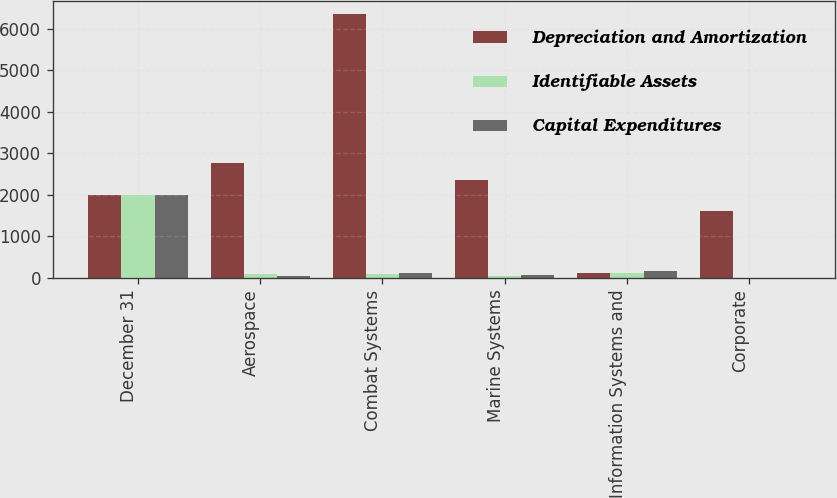Convert chart. <chart><loc_0><loc_0><loc_500><loc_500><stacked_bar_chart><ecel><fcel>December 31<fcel>Aerospace<fcel>Combat Systems<fcel>Marine Systems<fcel>Information Systems and<fcel>Corporate<nl><fcel>Depreciation and Amortization<fcel>2006<fcel>2755<fcel>6347<fcel>2347<fcel>112<fcel>1604<nl><fcel>Identifiable Assets<fcel>2006<fcel>86<fcel>92<fcel>40<fcel>112<fcel>4<nl><fcel>Capital Expenditures<fcel>2006<fcel>47<fcel>108<fcel>57<fcel>165<fcel>7<nl></chart> 